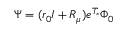<formula> <loc_0><loc_0><loc_500><loc_500>\Psi = ( r _ { 0 } I + R _ { \mu } ) e ^ { T _ { * } } \Phi _ { 0 }</formula> 